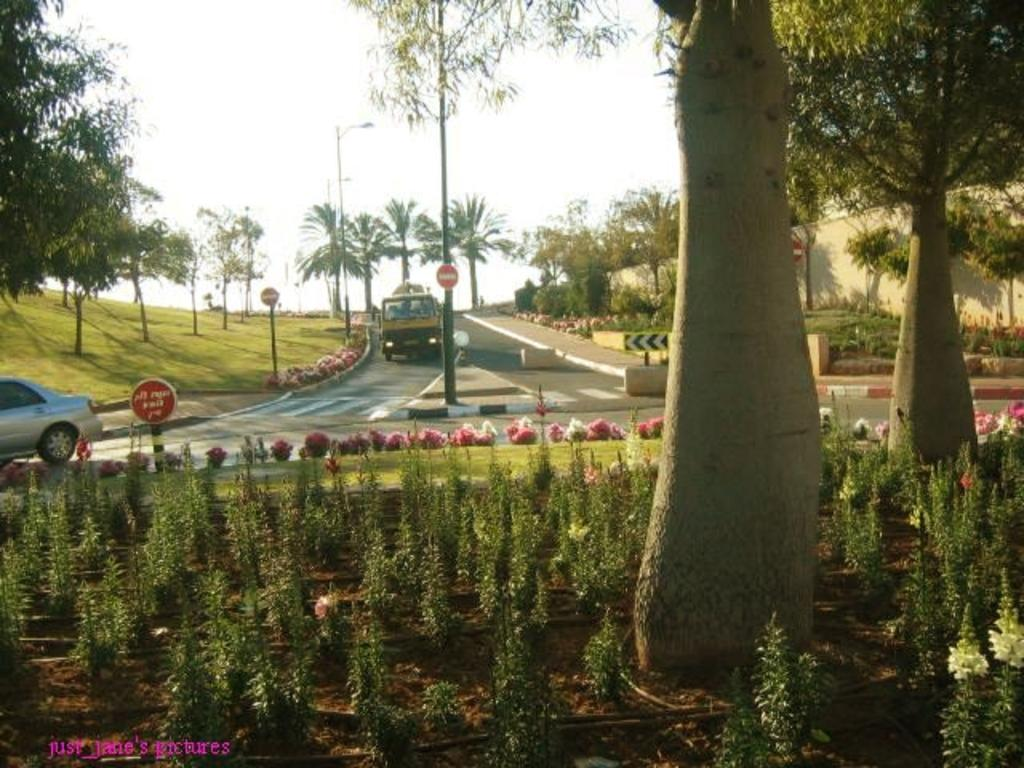What type of vegetation can be seen on the ground in the image? There are plants on the ground in the image. What type of ground cover is visible in the image? There is grass visible in the image. What type of tall vegetation is present in the image? There are trees in the image. What type of structures can be seen in the image? There are poles and signboards in the image. What type of transportation is present in the image? There are vehicles on the road in the image. What type of barrier is present in the image? There is a wall in the image. What can be seen in the background of the image? The sky is visible in the background of the image. What type of lettuce is being used as a crown in the image? There is no lettuce or crown present in the image. What historical event is being commemorated in the image? There is no indication of a historical event in the image. 